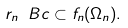<formula> <loc_0><loc_0><loc_500><loc_500>r _ { n } \ B c \subset f _ { n } ( \Omega _ { n } ) .</formula> 